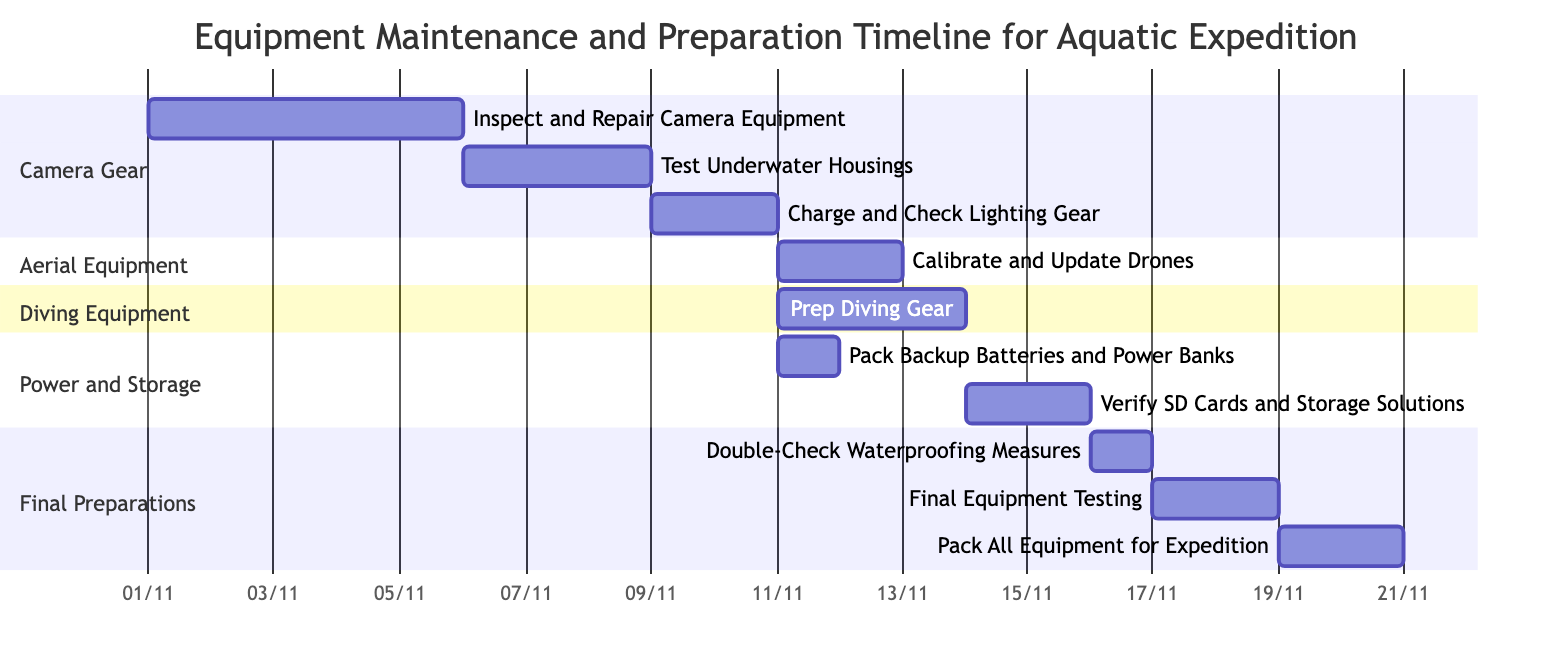What is the duration of the task "Inspect and Repair Camera Equipment"? The task "Inspect and Repair Camera Equipment" starts on November 1, 2023, and ends on November 5, 2023. This gives a total duration of 5 days.
Answer: 5 days Which task follows "Test Underwater Housings"? "Test Underwater Housings" has a dependency on the completion of "Inspect and Repair Camera Equipment". Following this task, "Charge and Check Lighting Gear" is scheduled, which starts immediately after "Test Underwater Housings" ends.
Answer: Charge and Check Lighting Gear How many tasks are scheduled between "Prep Diving Gear" and "Pack All Equipment for Expedition"? "Prep Diving Gear" ends on November 15, 2023, while "Pack All Equipment for Expedition" starts on November 22, 2023. Verifying the intervening tasks, we identify "Verify SD Cards and Storage Solutions", "Double-Check Waterproofing Measures", and "Final Equipment Testing". Therefore, there are three tasks scheduled in between.
Answer: 3 What is the earliest start date for any task in this Gantt chart? The earliest start date of any task is November 1, 2023, which is when "Inspect and Repair Camera Equipment" begins.
Answer: November 1, 2023 Which task has the highest number of dependencies? "Verify SD Cards and Storage Solutions" has the highest number of dependencies; it is dependent on "Prep Diving Gear". In total, it depends on the completion of three prior tasks: "Charge and Check Lighting Gear" and "Prep Diving Gear" (on the diving equipment section).
Answer: Verify SD Cards and Storage Solutions How many total sections are present in the Gantt chart? The Gantt chart comprises four distinct sections: Camera Gear, Aerial Equipment, Diving Equipment, and Power and Storage, along with Final Preparations.
Answer: 5 What is the last task scheduled in the Gantt chart? The last task in the Gantt chart is "Pack All Equipment for Expedition," which is followed by no further activities in the timeline.
Answer: Pack All Equipment for Expedition What is the total duration from the start of "Inspect and Repair Camera Equipment" to the end of "Pack All Equipment for Expedition"? The timeline starts from November 1, 2023 (beginning of "Inspect and Repair Camera Equipment") and ends on November 23, 2023 (end of "Pack All Equipment for Expedition"). This spans a total of 23 days.
Answer: 23 days 